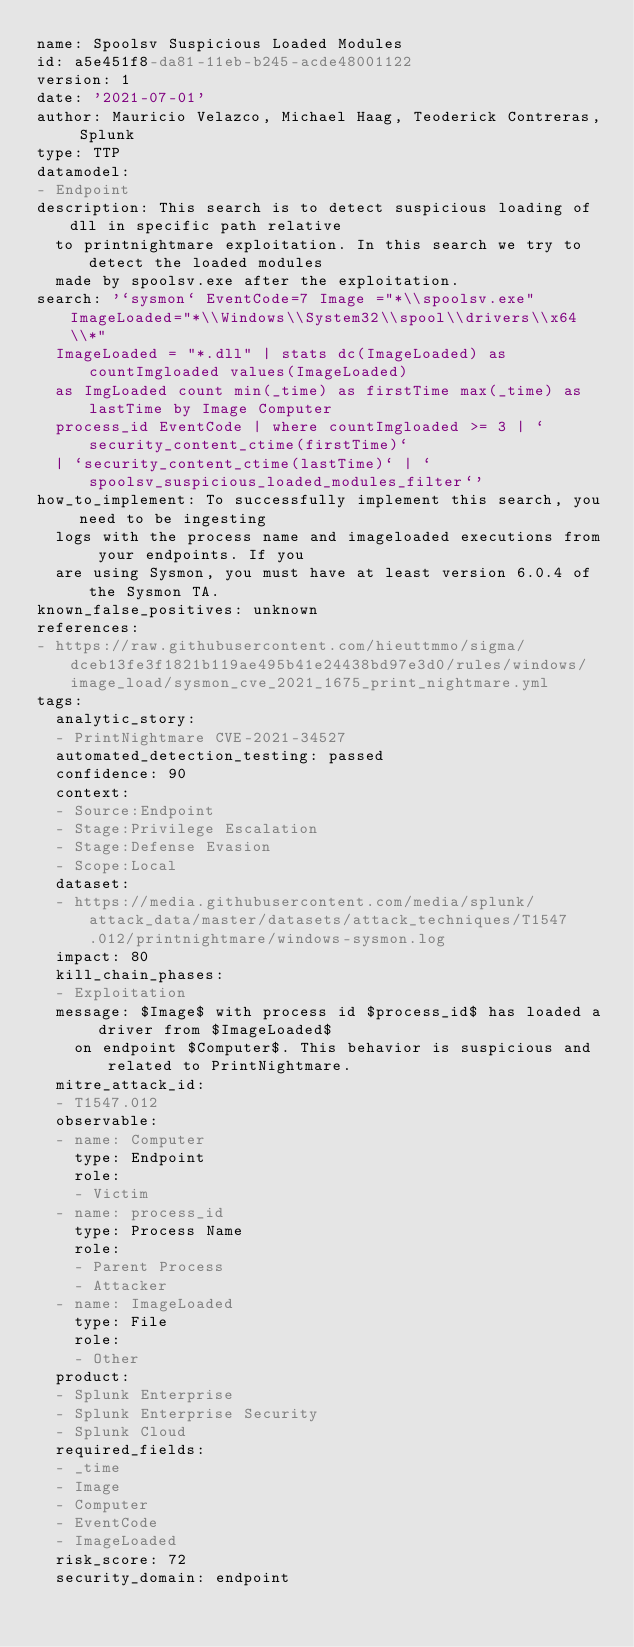<code> <loc_0><loc_0><loc_500><loc_500><_YAML_>name: Spoolsv Suspicious Loaded Modules
id: a5e451f8-da81-11eb-b245-acde48001122
version: 1
date: '2021-07-01'
author: Mauricio Velazco, Michael Haag, Teoderick Contreras, Splunk
type: TTP
datamodel:
- Endpoint
description: This search is to detect suspicious loading of dll in specific path relative
  to printnightmare exploitation. In this search we try to detect the loaded modules
  made by spoolsv.exe after the exploitation.
search: '`sysmon` EventCode=7 Image ="*\\spoolsv.exe" ImageLoaded="*\\Windows\\System32\\spool\\drivers\\x64\\*"
  ImageLoaded = "*.dll" | stats dc(ImageLoaded) as countImgloaded values(ImageLoaded)
  as ImgLoaded count min(_time) as firstTime max(_time) as lastTime by Image Computer
  process_id EventCode | where countImgloaded >= 3 | `security_content_ctime(firstTime)`
  | `security_content_ctime(lastTime)` | `spoolsv_suspicious_loaded_modules_filter`'
how_to_implement: To successfully implement this search, you need to be ingesting
  logs with the process name and imageloaded executions from your endpoints. If you
  are using Sysmon, you must have at least version 6.0.4 of the Sysmon TA.
known_false_positives: unknown
references:
- https://raw.githubusercontent.com/hieuttmmo/sigma/dceb13fe3f1821b119ae495b41e24438bd97e3d0/rules/windows/image_load/sysmon_cve_2021_1675_print_nightmare.yml
tags:
  analytic_story:
  - PrintNightmare CVE-2021-34527
  automated_detection_testing: passed
  confidence: 90
  context:
  - Source:Endpoint
  - Stage:Privilege Escalation
  - Stage:Defense Evasion
  - Scope:Local
  dataset:
  - https://media.githubusercontent.com/media/splunk/attack_data/master/datasets/attack_techniques/T1547.012/printnightmare/windows-sysmon.log
  impact: 80
  kill_chain_phases:
  - Exploitation
  message: $Image$ with process id $process_id$ has loaded a driver from $ImageLoaded$
    on endpoint $Computer$. This behavior is suspicious and related to PrintNightmare.
  mitre_attack_id:
  - T1547.012
  observable:
  - name: Computer
    type: Endpoint
    role:
    - Victim
  - name: process_id
    type: Process Name
    role:
    - Parent Process
    - Attacker
  - name: ImageLoaded
    type: File
    role:
    - Other
  product:
  - Splunk Enterprise
  - Splunk Enterprise Security
  - Splunk Cloud
  required_fields:
  - _time
  - Image
  - Computer
  - EventCode
  - ImageLoaded
  risk_score: 72
  security_domain: endpoint
</code> 